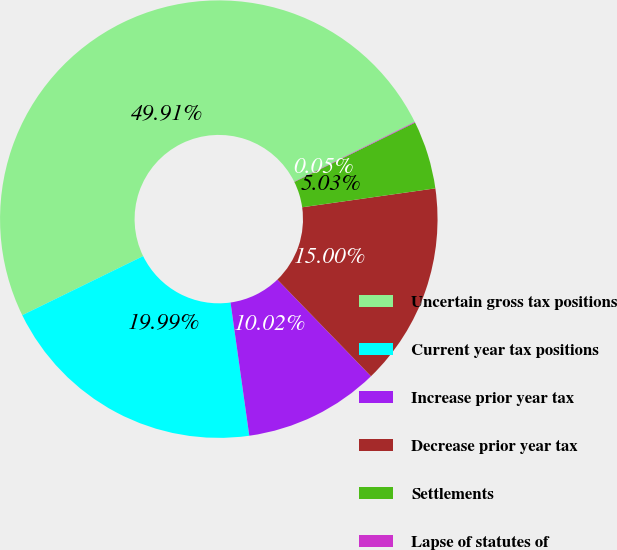<chart> <loc_0><loc_0><loc_500><loc_500><pie_chart><fcel>Uncertain gross tax positions<fcel>Current year tax positions<fcel>Increase prior year tax<fcel>Decrease prior year tax<fcel>Settlements<fcel>Lapse of statutes of<nl><fcel>49.91%<fcel>19.99%<fcel>10.02%<fcel>15.0%<fcel>5.03%<fcel>0.05%<nl></chart> 